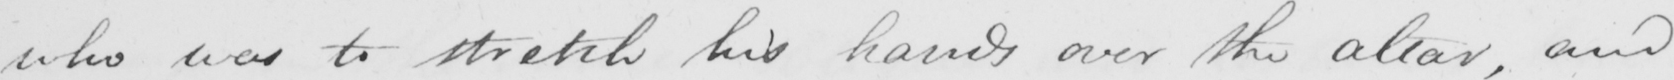What text is written in this handwritten line? who was to stretch his hands over the altar , and 